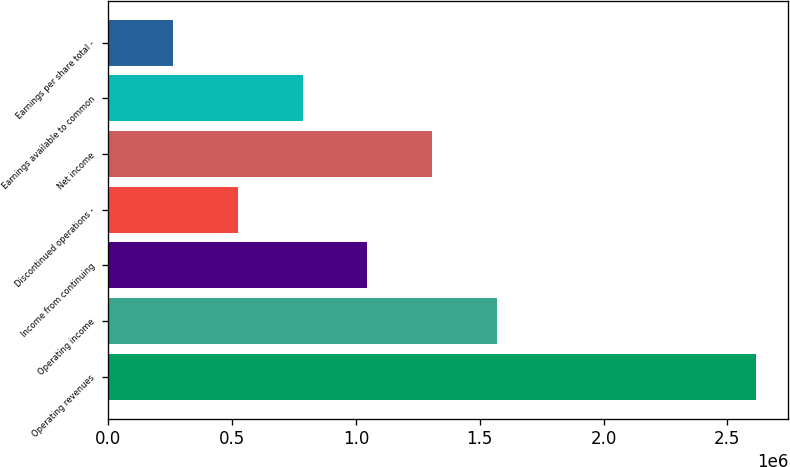Convert chart to OTSL. <chart><loc_0><loc_0><loc_500><loc_500><bar_chart><fcel>Operating revenues<fcel>Operating income<fcel>Income from continuing<fcel>Discontinued operations -<fcel>Net income<fcel>Earnings available to common<fcel>Earnings per share total -<nl><fcel>2.61552e+06<fcel>1.56931e+06<fcel>1.04621e+06<fcel>523103<fcel>1.30776e+06<fcel>784655<fcel>261552<nl></chart> 